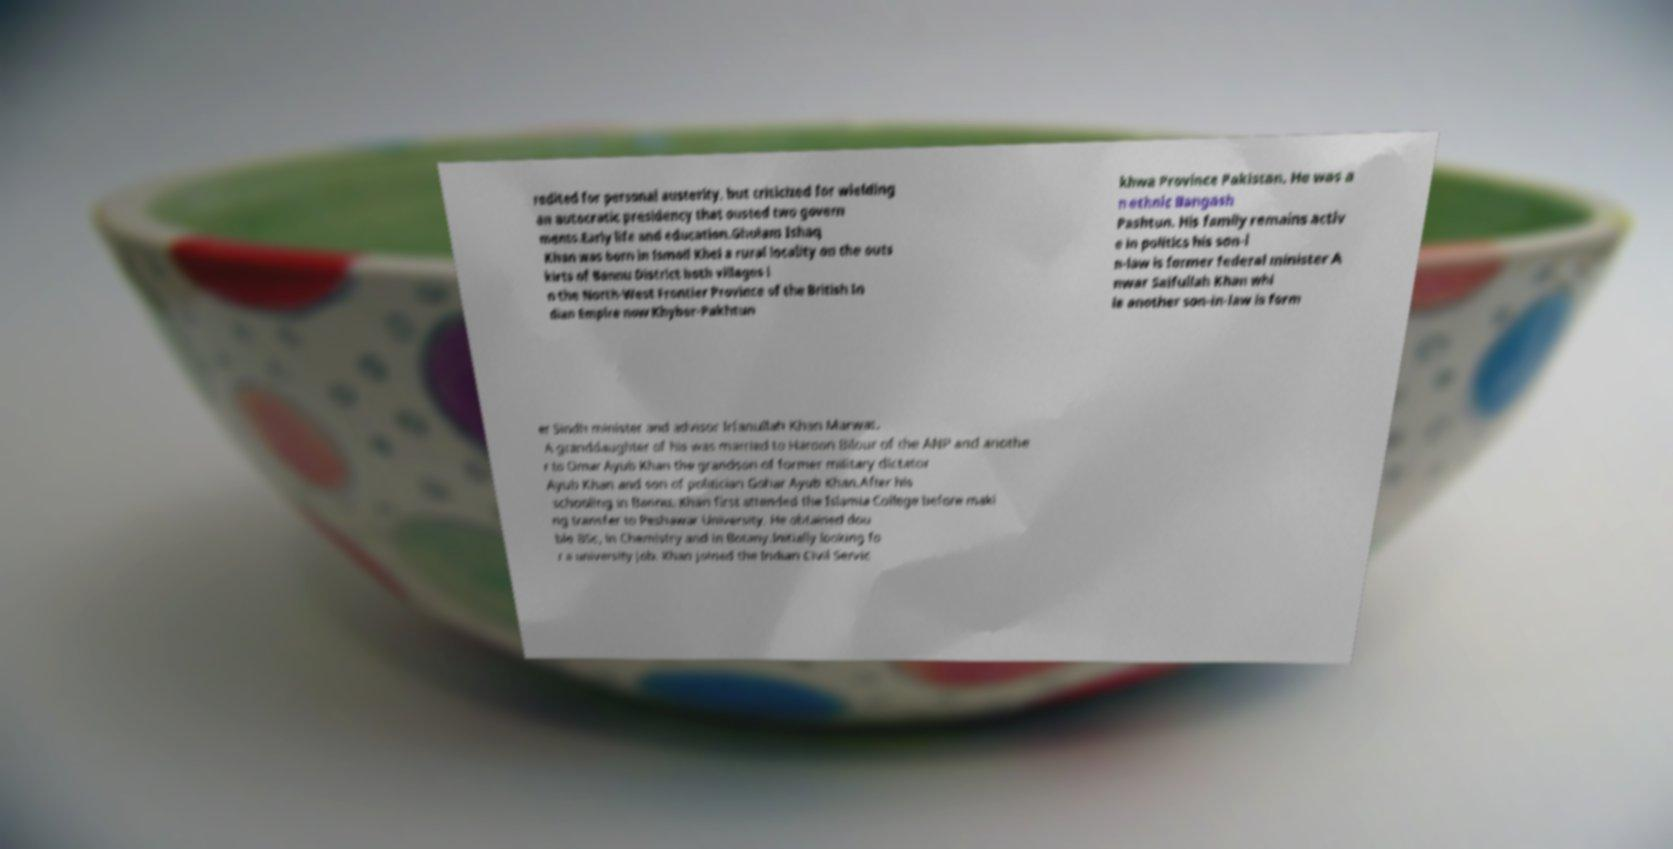I need the written content from this picture converted into text. Can you do that? redited for personal austerity, but criticized for wielding an autocratic presidency that ousted two govern ments.Early life and education.Ghulam Ishaq Khan was born in Ismail Khel a rural locality on the outs kirts of Bannu District both villages i n the North-West Frontier Province of the British In dian Empire now Khyber-Pakhtun khwa Province Pakistan. He was a n ethnic Bangash Pashtun. His family remains activ e in politics his son-i n-law is former federal minister A nwar Saifullah Khan whi le another son-in-law is form er Sindh minister and advisor Irfanullah Khan Marwat. A granddaughter of his was married to Haroon Bilour of the ANP and anothe r to Omar Ayub Khan the grandson of former military dictator Ayub Khan and son of politician Gohar Ayub Khan.After his schooling in Bannu, Khan first attended the Islamia College before maki ng transfer to Peshawar University. He obtained dou ble BSc, in Chemistry and in Botany.Initially looking fo r a university job, Khan joined the Indian Civil Servic 